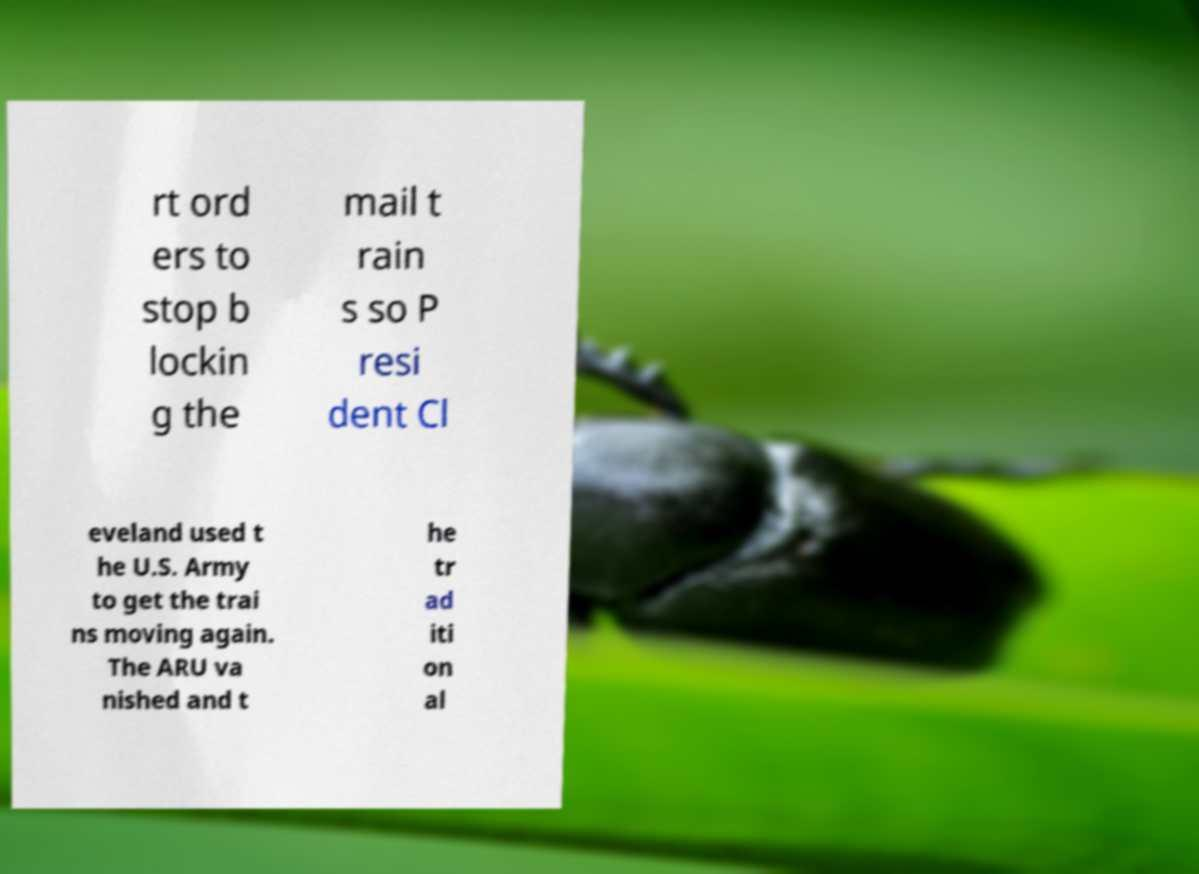Could you extract and type out the text from this image? rt ord ers to stop b lockin g the mail t rain s so P resi dent Cl eveland used t he U.S. Army to get the trai ns moving again. The ARU va nished and t he tr ad iti on al 